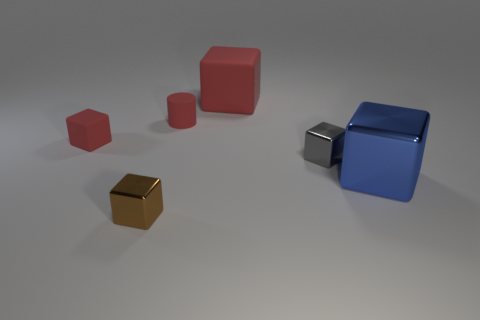Can you tell if the light source in the image is natural or artificial, and from which direction is it coming? The lighting in the image appears to be artificial, characterized by the soft shadows and the diffuse illumination. It seems to emanate from above and slightly to the left, as indicated by the positions of the shadows cast by the objects. 